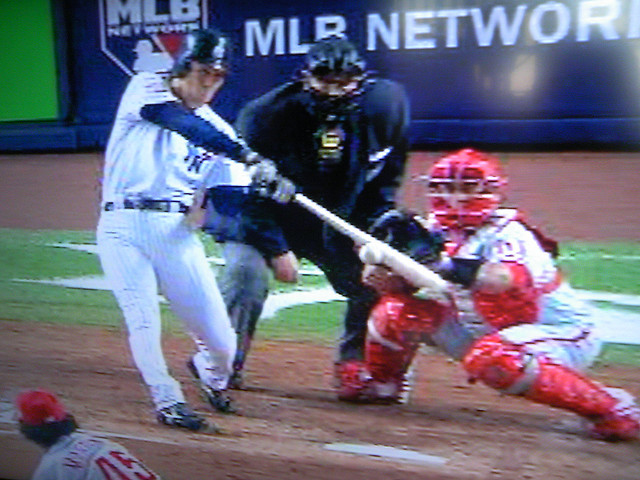Extract all visible text content from this image. MLR NETWOR MLB 